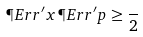Convert formula to latex. <formula><loc_0><loc_0><loc_500><loc_500>\P E r r ^ { \prime } x \, \P E r r ^ { \prime } p \geq \frac { } { 2 }</formula> 